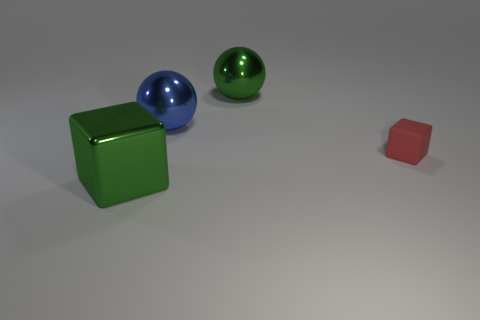Can you describe the positioning of the objects in relation to each other? Certainly! In the image, there's a large green cube positioned closer to the viewer, with a small red cube in front of it. Slightly further back, centered in the image, is a reflective blue sphere, and to the right of the blue sphere is a smaller green sphere with a matte finish. 